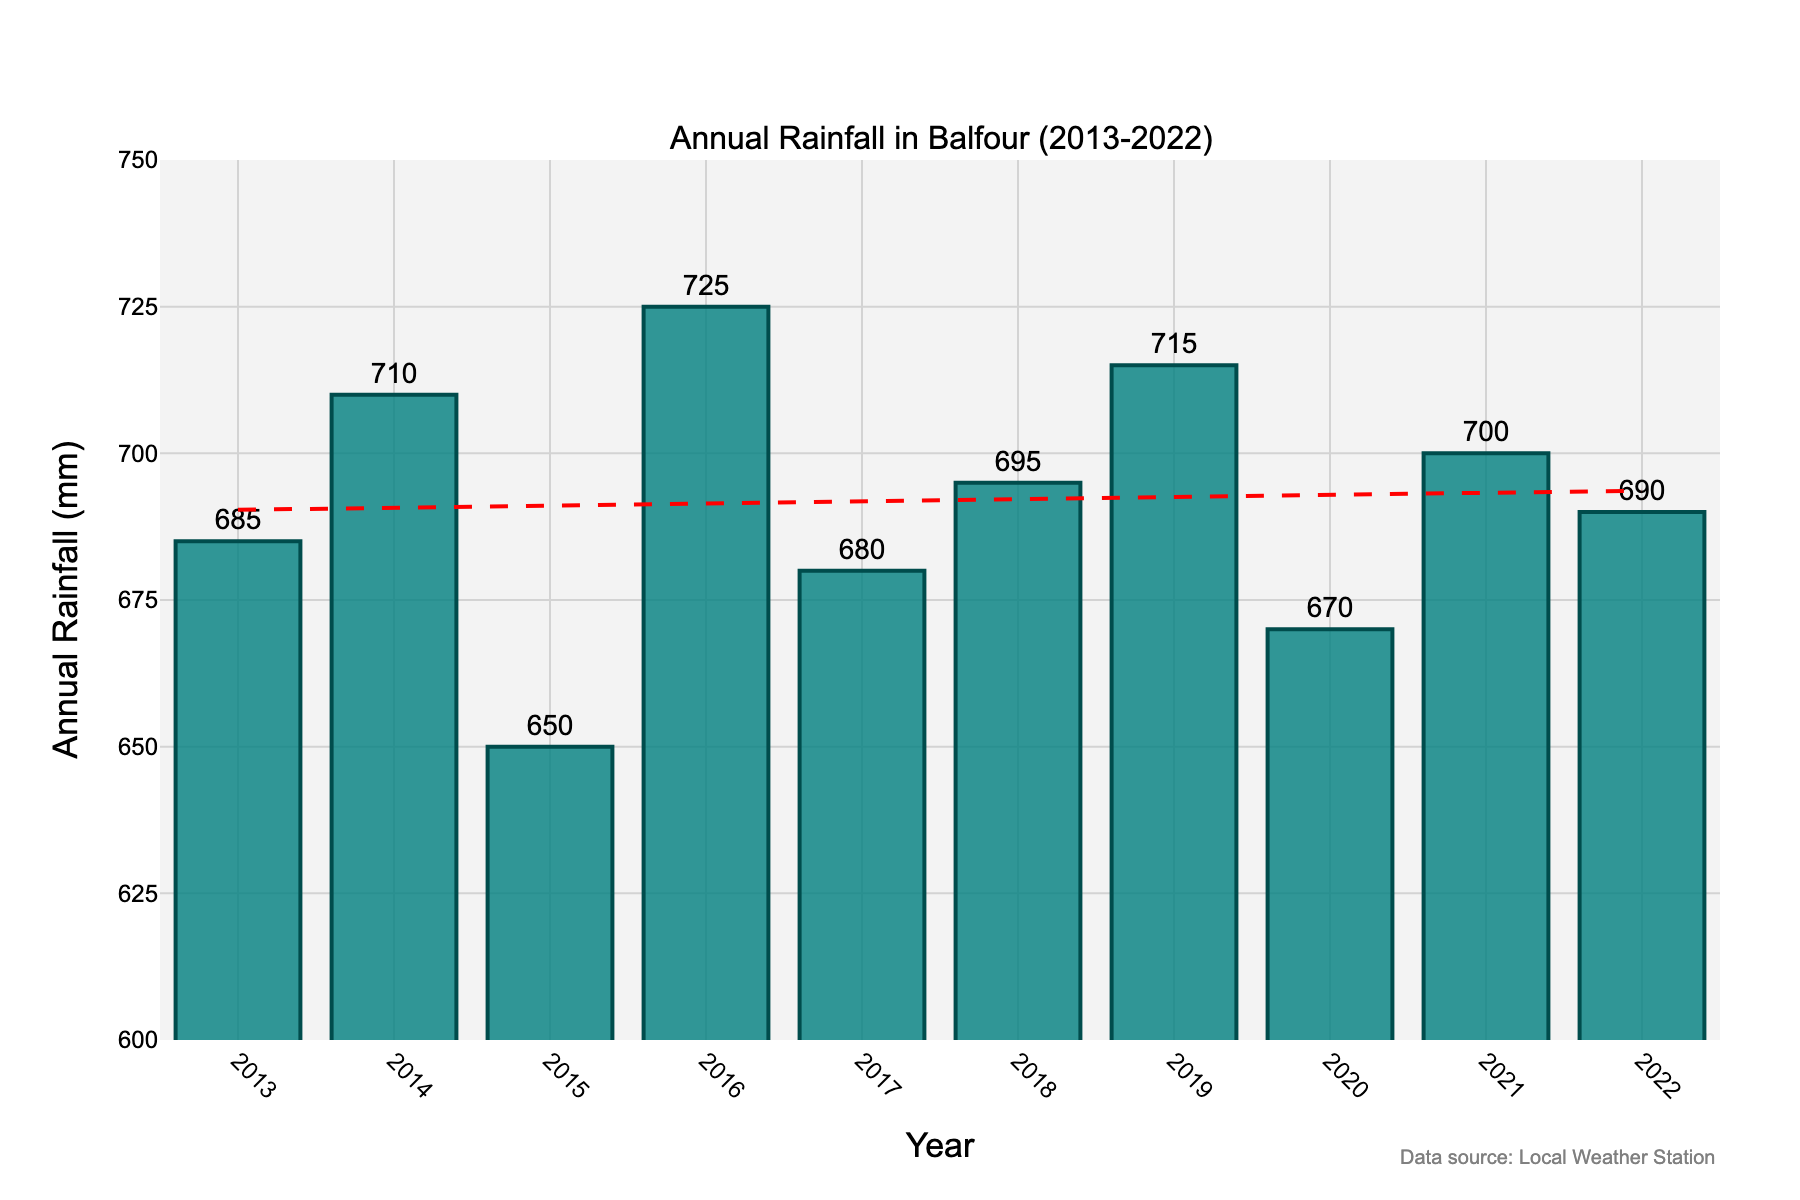What's the highest annual rainfall recorded in the past decade in Balfour? To find the highest annual rainfall, scan through the bar heights and hover texts in the plot to identify the maximum value.
Answer: 725 mm What's the average annual rainfall in Balfour over the past decade? Sum all the annual rainfall values and divide by the number of years. (685 + 710 + 650 + 725 + 680 + 695 + 715 + 670 + 700 + 690) / 10 = 6920 / 10
Answer: 692 mm Which year experienced the lowest rainfall? Look at the bar chart and identify the bar with the smallest height. According to the plot, find the year this occurs.
Answer: 2015 What is the difference in rainfall between the year with the highest and the lowest rainfall? Identify the highest (725 mm in 2016) and the lowest (650 mm in 2015) rainfall from the plot and subtract the low from the high: 725 - 650.
Answer: 75 mm Looking at the trend line, does the annual rainfall in Balfour appear to be increasing or decreasing over the past decade? Observe the direction of the red dashed trend line in the plot to determine the general trend. The line slightly declines over time.
Answer: Decreasing Which two consecutive years had the biggest increase in rainfall? Check the differences between each pair of consecutive years by subtracting the rainfall of the earlier year from the later year to find the maximum increase. (710 - 685 = 25, 650 - 710 = -60, 725 - 650 = 75, 680 - 725 = -45, 695 - 680 = 15, 715 - 695 = 20, 670 - 715 = -45, 700 - 670 = 30, 690 - 700 = -10). The biggest increase is between 2015 and 2016.
Answer: 2015 and 2016 Do bars representing even or odd years have a higher average rainfall? Separate the rainfall values for even (2014, 2016, 2018, 2020, 2022: 710, 725, 695, 670, 690) and odd years (2013, 2015, 2017, 2019, 2021: 685, 650, 680, 715, 700). Calculate and compare the average: (710 + 725 + 695 + 670 + 690) / 5 = 698 mm and (685 + 650 + 680 + 715 + 700) / 5 = 686 mm.
Answer: Even years What was the total rainfall in the first half (2013-2017) of the decade? Add annual rainfall values for the years 2013 to 2017: 685 + 710 + 650 + 725 + 680.
Answer: 3450 mm How many years did the rainfall exceed 700 mm? Count the number of bars that have heights, and hover text value more than 700 mm (2014, 2016, 2019, 2021).
Answer: 4 Is the trend line above or below the actual rainfall in 2020? Compare the position of the red dashed trend line to the height of the bar for the year 2020. The trend line is visibly above the actual bar representing 2020.
Answer: Above 